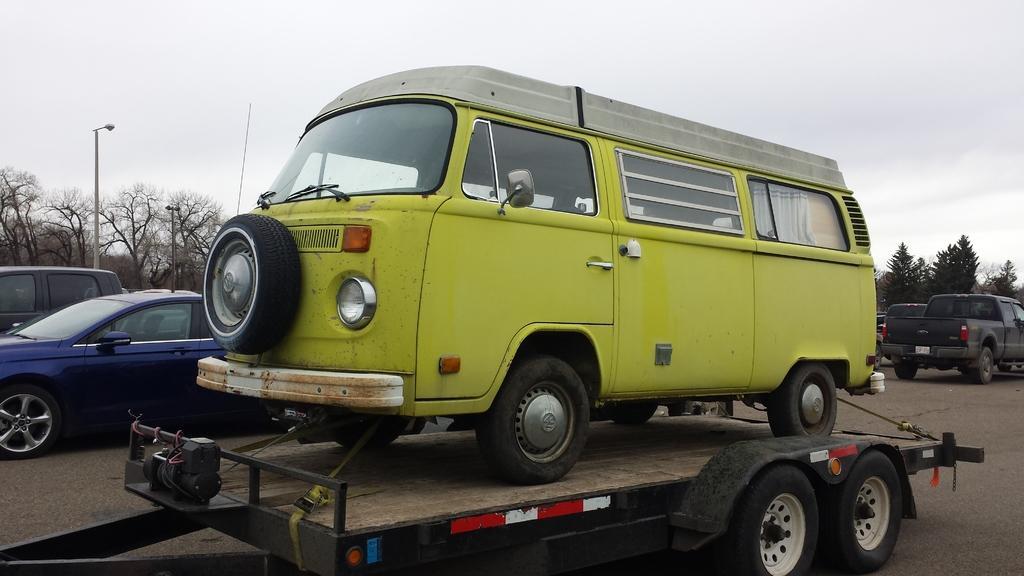Can you describe this image briefly? In the foreground of the picture it is road, on the road there are many vehicles like car, van and other. On the left there are trees and street light. On the right there are trees. In the background it is sky, sky is cloudy. 